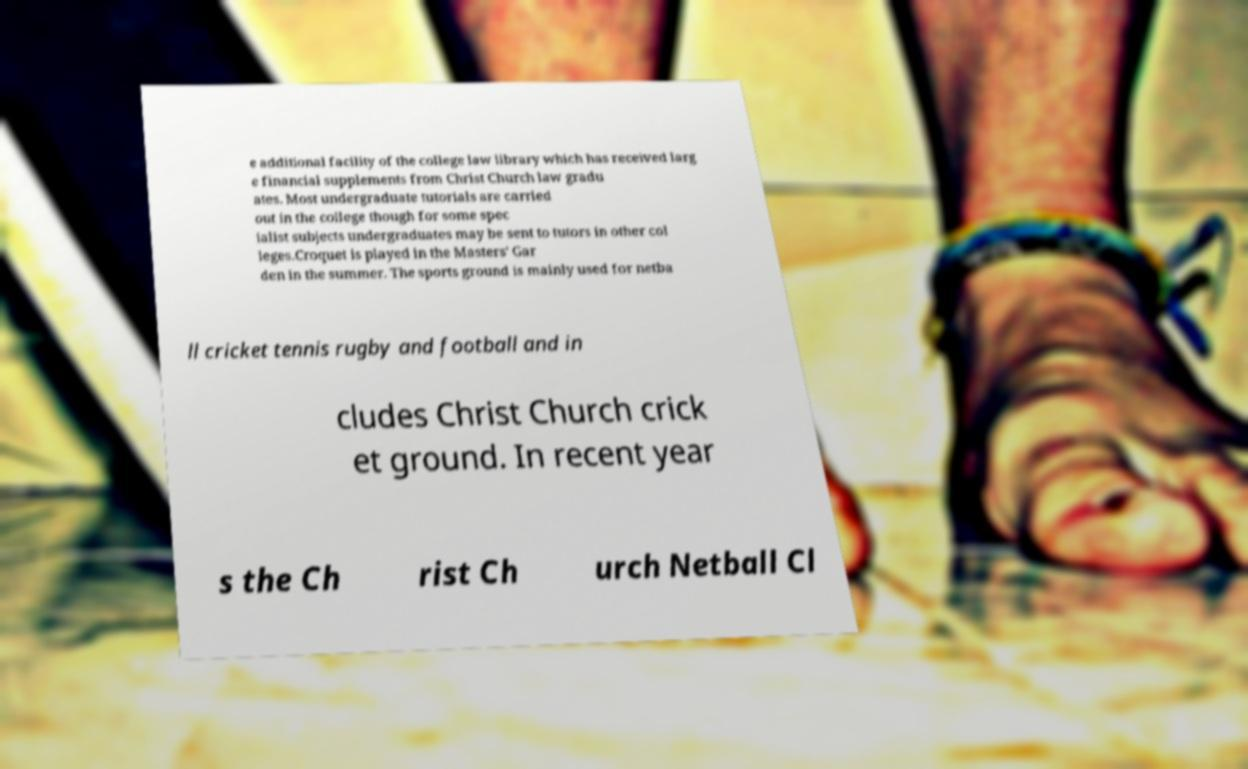Can you accurately transcribe the text from the provided image for me? e additional facility of the college law library which has received larg e financial supplements from Christ Church law gradu ates. Most undergraduate tutorials are carried out in the college though for some spec ialist subjects undergraduates may be sent to tutors in other col leges.Croquet is played in the Masters' Gar den in the summer. The sports ground is mainly used for netba ll cricket tennis rugby and football and in cludes Christ Church crick et ground. In recent year s the Ch rist Ch urch Netball Cl 